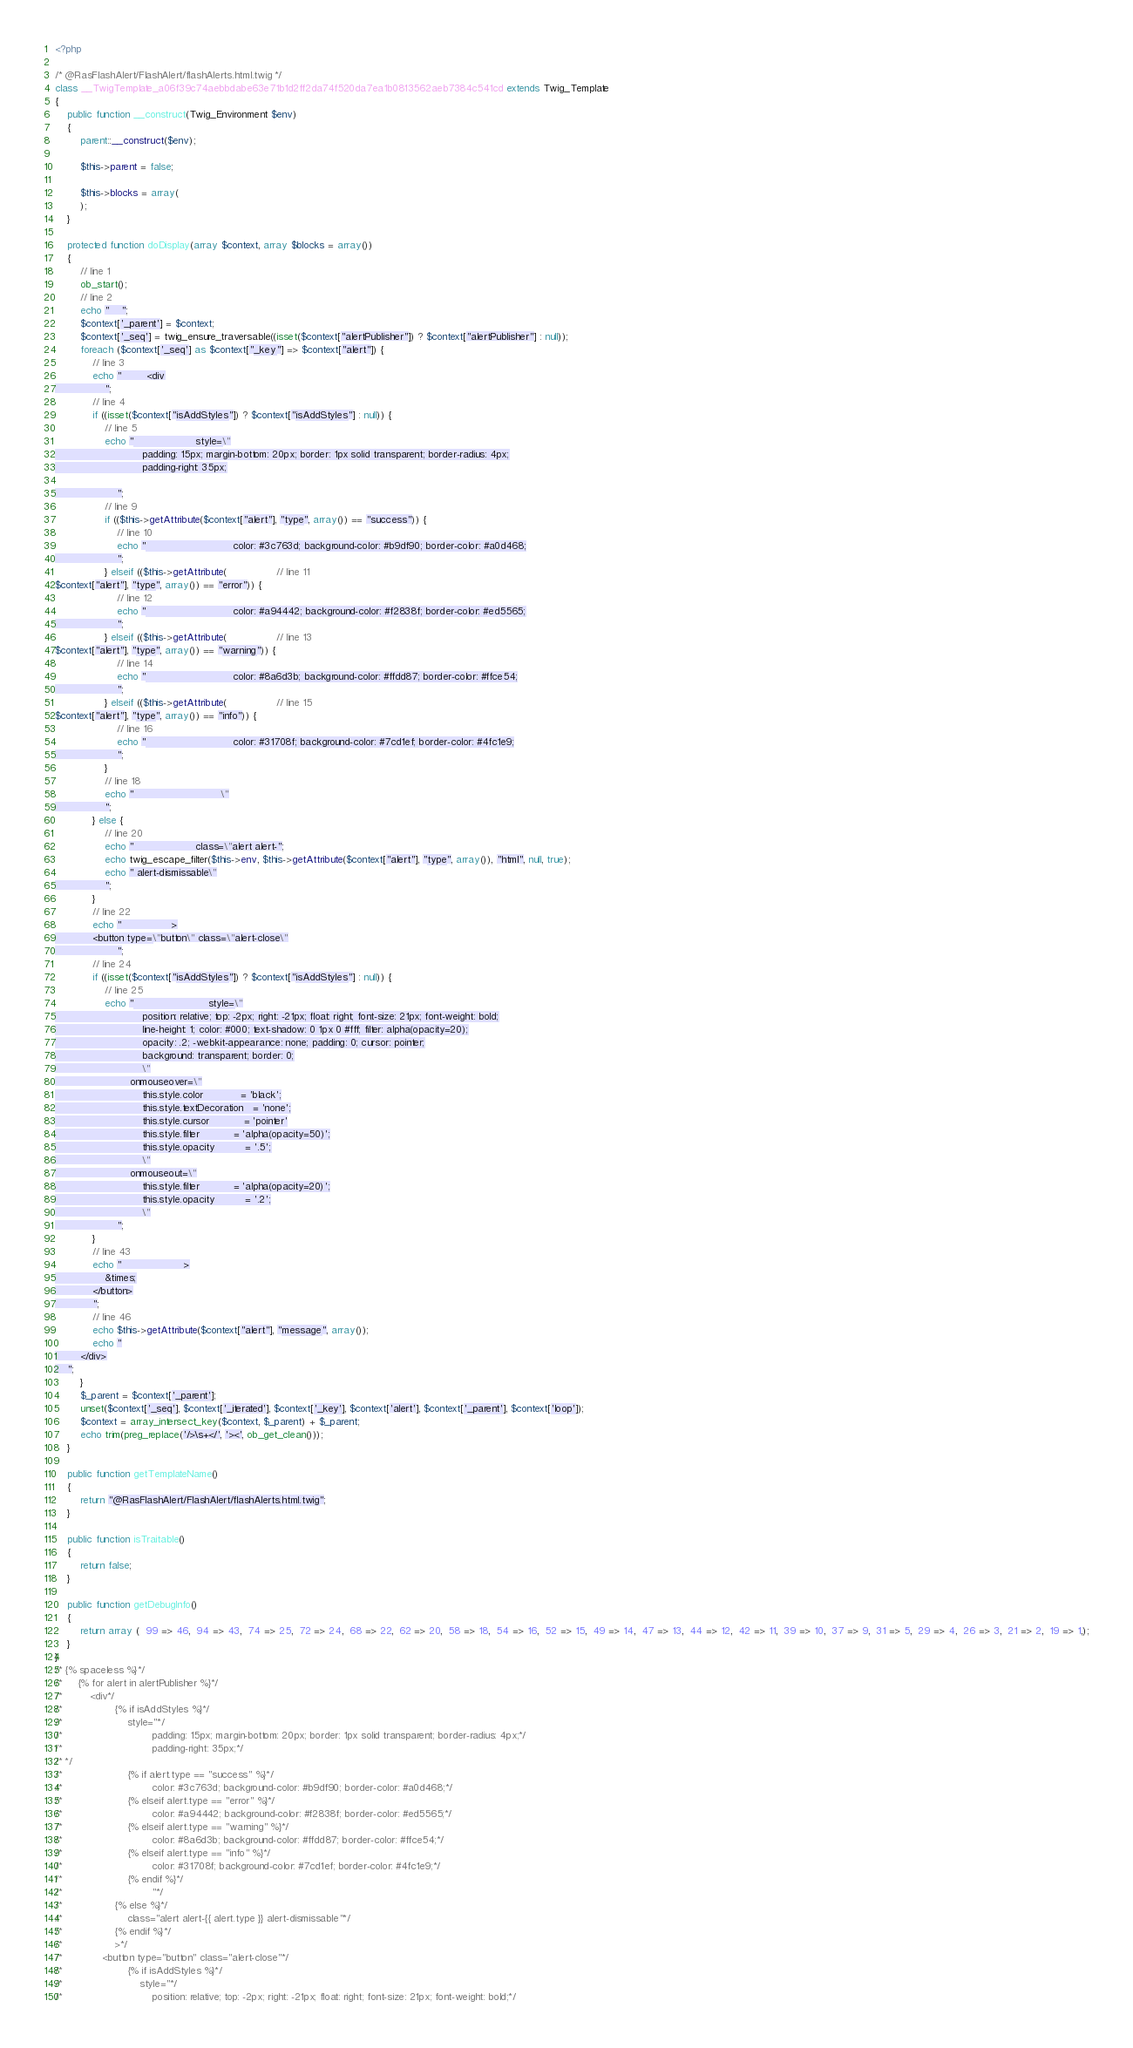<code> <loc_0><loc_0><loc_500><loc_500><_PHP_><?php

/* @RasFlashAlert/FlashAlert/flashAlerts.html.twig */
class __TwigTemplate_a06f39c74aebbdabe63e71b1d2ff2da74f520da7ea1b0813562aeb7384c541cd extends Twig_Template
{
    public function __construct(Twig_Environment $env)
    {
        parent::__construct($env);

        $this->parent = false;

        $this->blocks = array(
        );
    }

    protected function doDisplay(array $context, array $blocks = array())
    {
        // line 1
        ob_start();
        // line 2
        echo "    ";
        $context['_parent'] = $context;
        $context['_seq'] = twig_ensure_traversable((isset($context["alertPublisher"]) ? $context["alertPublisher"] : null));
        foreach ($context['_seq'] as $context["_key"] => $context["alert"]) {
            // line 3
            echo "        <div
                ";
            // line 4
            if ((isset($context["isAddStyles"]) ? $context["isAddStyles"] : null)) {
                // line 5
                echo "                    style=\"
                            padding: 15px; margin-bottom: 20px; border: 1px solid transparent; border-radius: 4px;
                            padding-right: 35px;

                    ";
                // line 9
                if (($this->getAttribute($context["alert"], "type", array()) == "success")) {
                    // line 10
                    echo "                            color: #3c763d; background-color: #b9df90; border-color: #a0d468;
                    ";
                } elseif (($this->getAttribute(                // line 11
$context["alert"], "type", array()) == "error")) {
                    // line 12
                    echo "                            color: #a94442; background-color: #f2838f; border-color: #ed5565;
                    ";
                } elseif (($this->getAttribute(                // line 13
$context["alert"], "type", array()) == "warning")) {
                    // line 14
                    echo "                            color: #8a6d3b; background-color: #ffdd87; border-color: #ffce54;
                    ";
                } elseif (($this->getAttribute(                // line 15
$context["alert"], "type", array()) == "info")) {
                    // line 16
                    echo "                            color: #31708f; background-color: #7cd1ef; border-color: #4fc1e9;
                    ";
                }
                // line 18
                echo "                            \"
                ";
            } else {
                // line 20
                echo "                    class=\"alert alert-";
                echo twig_escape_filter($this->env, $this->getAttribute($context["alert"], "type", array()), "html", null, true);
                echo " alert-dismissable\"
                ";
            }
            // line 22
            echo "                >
            <button type=\"button\" class=\"alert-close\"
                    ";
            // line 24
            if ((isset($context["isAddStyles"]) ? $context["isAddStyles"] : null)) {
                // line 25
                echo "                        style=\"
                            position: relative; top: -2px; right: -21px; float: right; font-size: 21px; font-weight: bold;
                            line-height: 1; color: #000; text-shadow: 0 1px 0 #fff; filter: alpha(opacity=20);
                            opacity: .2; -webkit-appearance: none; padding: 0; cursor: pointer;
                            background: transparent; border: 0;
                            \"
                        onmouseover=\"
                            this.style.color            = 'black';
                            this.style.textDecoration   = 'none';
                            this.style.cursor           = 'pointer'
                            this.style.filter           = 'alpha(opacity=50)';
                            this.style.opacity          = '.5';
                            \"
                        onmouseout=\"
                            this.style.filter           = 'alpha(opacity=20)';
                            this.style.opacity          = '.2';
                            \"
                    ";
            }
            // line 43
            echo "                    >
                &times;
            </button>
            ";
            // line 46
            echo $this->getAttribute($context["alert"], "message", array());
            echo "
        </div>
    ";
        }
        $_parent = $context['_parent'];
        unset($context['_seq'], $context['_iterated'], $context['_key'], $context['alert'], $context['_parent'], $context['loop']);
        $context = array_intersect_key($context, $_parent) + $_parent;
        echo trim(preg_replace('/>\s+</', '><', ob_get_clean()));
    }

    public function getTemplateName()
    {
        return "@RasFlashAlert/FlashAlert/flashAlerts.html.twig";
    }

    public function isTraitable()
    {
        return false;
    }

    public function getDebugInfo()
    {
        return array (  99 => 46,  94 => 43,  74 => 25,  72 => 24,  68 => 22,  62 => 20,  58 => 18,  54 => 16,  52 => 15,  49 => 14,  47 => 13,  44 => 12,  42 => 11,  39 => 10,  37 => 9,  31 => 5,  29 => 4,  26 => 3,  21 => 2,  19 => 1,);
    }
}
/* {% spaceless %}*/
/*     {% for alert in alertPublisher %}*/
/*         <div*/
/*                 {% if isAddStyles %}*/
/*                     style="*/
/*                             padding: 15px; margin-bottom: 20px; border: 1px solid transparent; border-radius: 4px;*/
/*                             padding-right: 35px;*/
/* */
/*                     {% if alert.type == "success" %}*/
/*                             color: #3c763d; background-color: #b9df90; border-color: #a0d468;*/
/*                     {% elseif alert.type == "error" %}*/
/*                             color: #a94442; background-color: #f2838f; border-color: #ed5565;*/
/*                     {% elseif alert.type == "warning" %}*/
/*                             color: #8a6d3b; background-color: #ffdd87; border-color: #ffce54;*/
/*                     {% elseif alert.type == "info" %}*/
/*                             color: #31708f; background-color: #7cd1ef; border-color: #4fc1e9;*/
/*                     {% endif %}*/
/*                             "*/
/*                 {% else %}*/
/*                     class="alert alert-{{ alert.type }} alert-dismissable"*/
/*                 {% endif %}*/
/*                 >*/
/*             <button type="button" class="alert-close"*/
/*                     {% if isAddStyles %}*/
/*                         style="*/
/*                             position: relative; top: -2px; right: -21px; float: right; font-size: 21px; font-weight: bold;*/</code> 